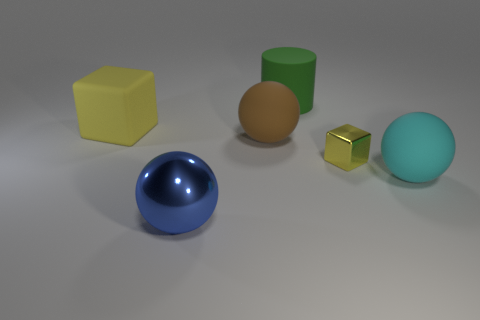Subtract all big brown rubber balls. How many balls are left? 2 Add 3 tiny red rubber cubes. How many objects exist? 9 Subtract 1 cylinders. How many cylinders are left? 0 Subtract all blue balls. How many balls are left? 2 Subtract all cylinders. How many objects are left? 5 Subtract all brown cylinders. Subtract all brown spheres. How many cylinders are left? 1 Subtract all blue balls. Subtract all tiny yellow objects. How many objects are left? 4 Add 5 brown objects. How many brown objects are left? 6 Add 6 yellow cylinders. How many yellow cylinders exist? 6 Subtract 0 green cubes. How many objects are left? 6 